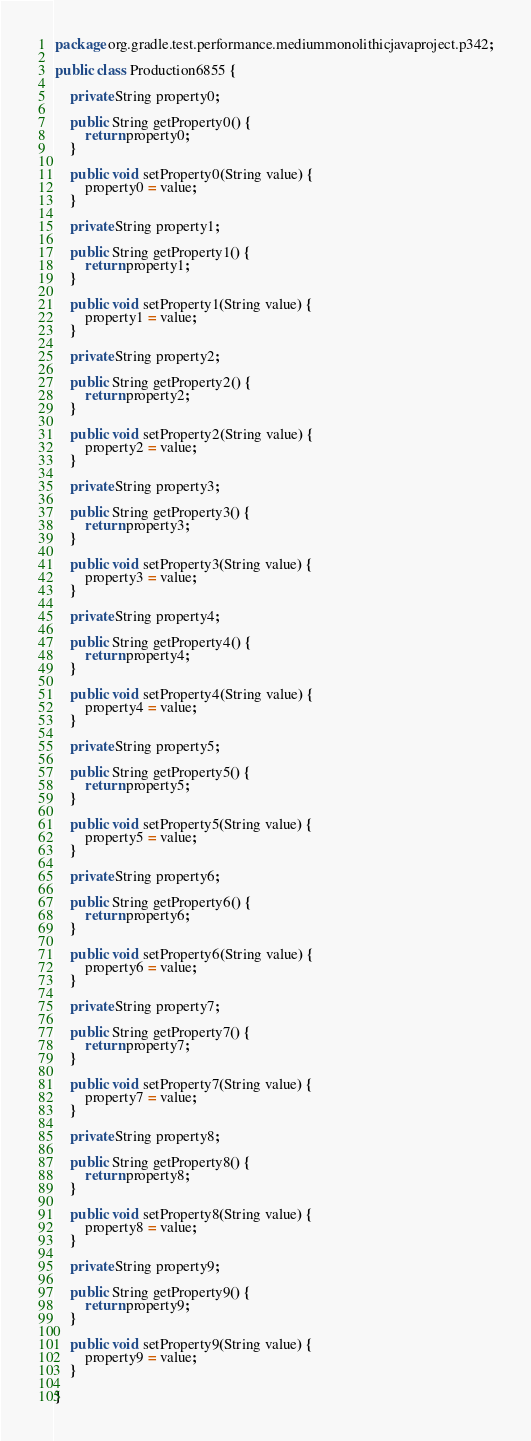Convert code to text. <code><loc_0><loc_0><loc_500><loc_500><_Java_>package org.gradle.test.performance.mediummonolithicjavaproject.p342;

public class Production6855 {        

    private String property0;

    public String getProperty0() {
        return property0;
    }

    public void setProperty0(String value) {
        property0 = value;
    }

    private String property1;

    public String getProperty1() {
        return property1;
    }

    public void setProperty1(String value) {
        property1 = value;
    }

    private String property2;

    public String getProperty2() {
        return property2;
    }

    public void setProperty2(String value) {
        property2 = value;
    }

    private String property3;

    public String getProperty3() {
        return property3;
    }

    public void setProperty3(String value) {
        property3 = value;
    }

    private String property4;

    public String getProperty4() {
        return property4;
    }

    public void setProperty4(String value) {
        property4 = value;
    }

    private String property5;

    public String getProperty5() {
        return property5;
    }

    public void setProperty5(String value) {
        property5 = value;
    }

    private String property6;

    public String getProperty6() {
        return property6;
    }

    public void setProperty6(String value) {
        property6 = value;
    }

    private String property7;

    public String getProperty7() {
        return property7;
    }

    public void setProperty7(String value) {
        property7 = value;
    }

    private String property8;

    public String getProperty8() {
        return property8;
    }

    public void setProperty8(String value) {
        property8 = value;
    }

    private String property9;

    public String getProperty9() {
        return property9;
    }

    public void setProperty9(String value) {
        property9 = value;
    }

}</code> 